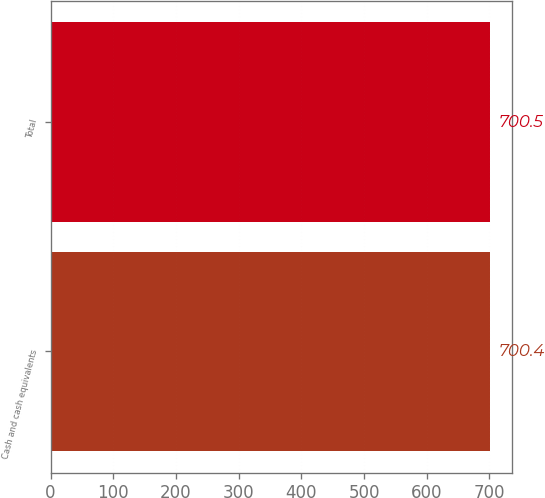<chart> <loc_0><loc_0><loc_500><loc_500><bar_chart><fcel>Cash and cash equivalents<fcel>Total<nl><fcel>700.4<fcel>700.5<nl></chart> 